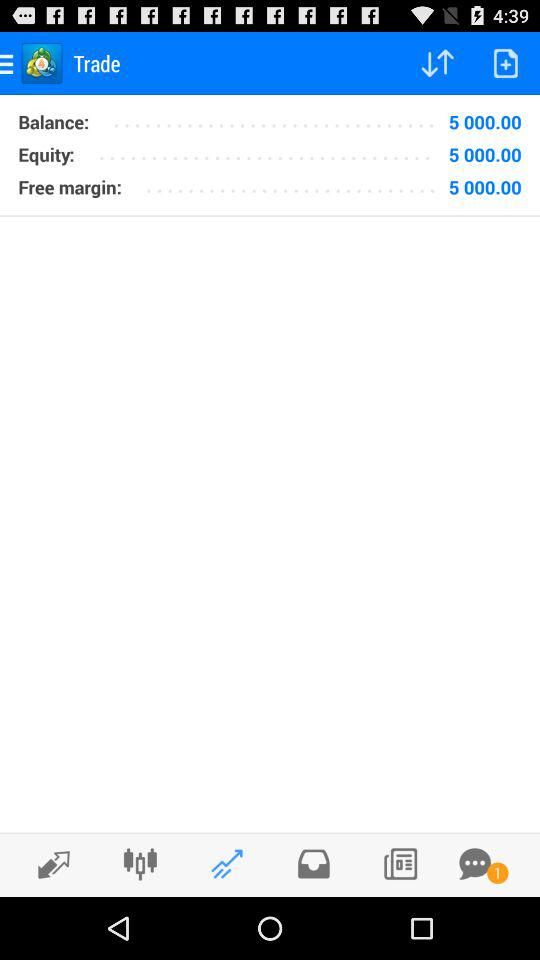Is there an unread message? There is 1 unread message. 